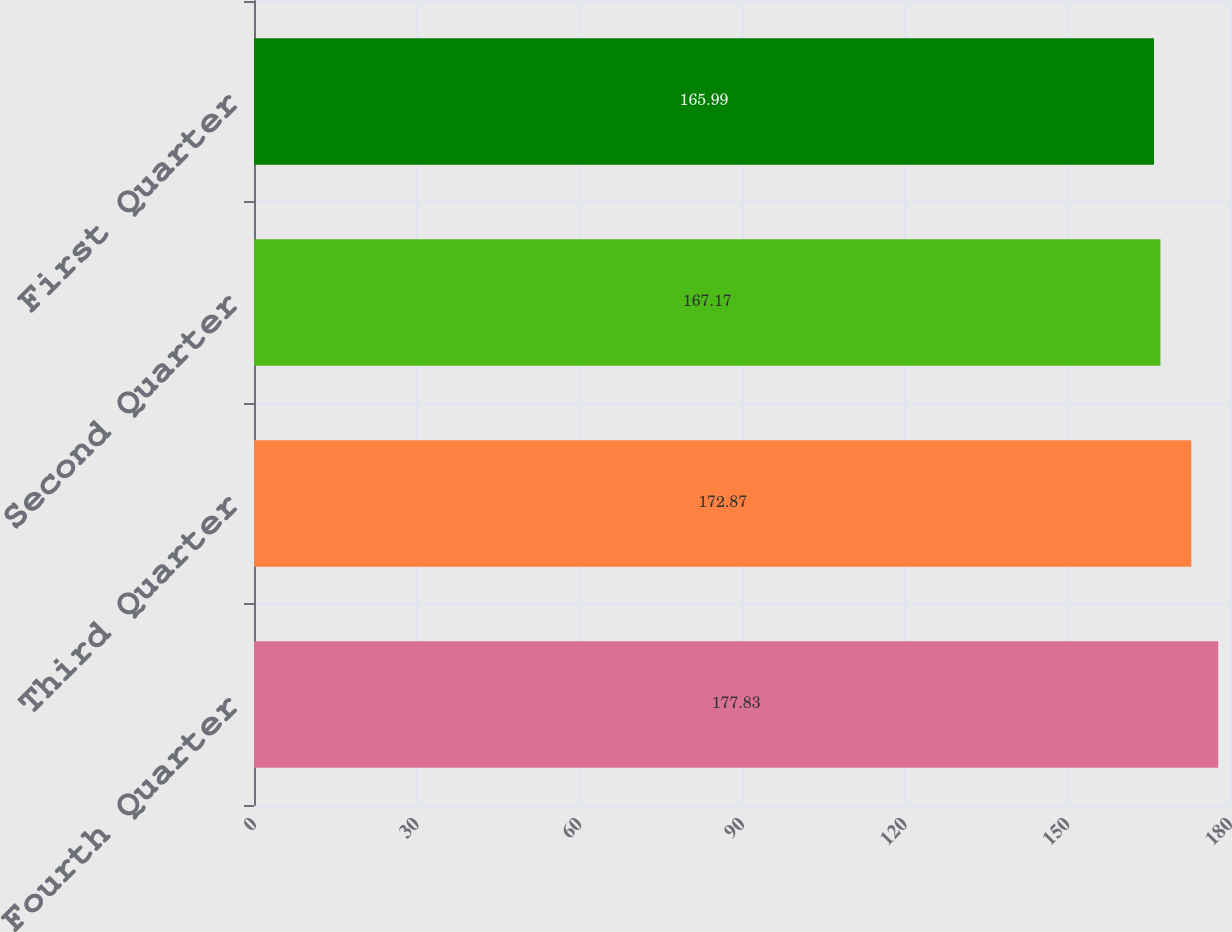<chart> <loc_0><loc_0><loc_500><loc_500><bar_chart><fcel>Fourth Quarter<fcel>Third Quarter<fcel>Second Quarter<fcel>First Quarter<nl><fcel>177.83<fcel>172.87<fcel>167.17<fcel>165.99<nl></chart> 